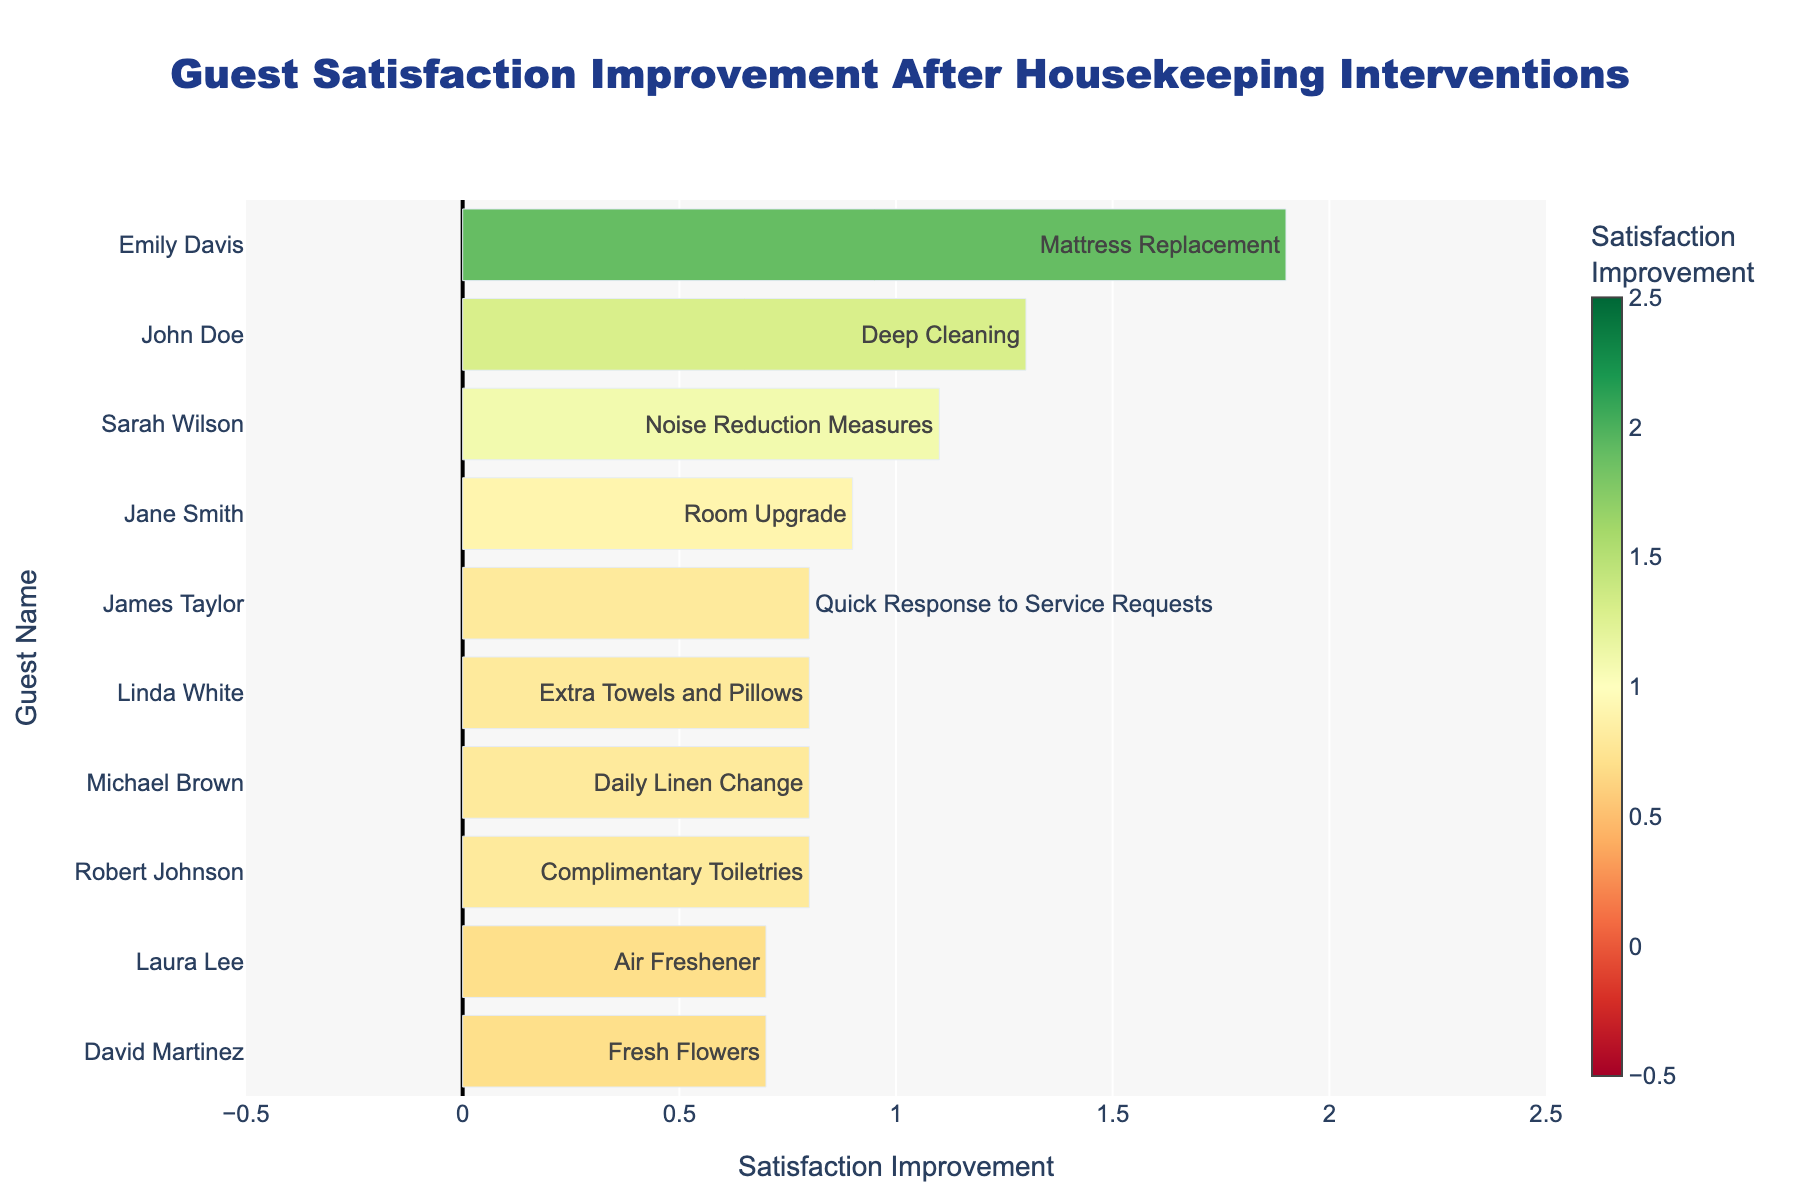what is the average satisfaction improvement of all guests? First, note the satisfaction improvements for all guests: [1.3, 0.9, 0.8, 1.9, 0.8, 1.1, 0.7, 0.7, 0.8, 0.8]. Sum these values: (1.3 + 0.9 + 0.8 + 1.9 + 0.8 + 1.1 + 0.7 + 0.7 + 0.8 + 0.8) = 9.8. Now, divide this sum by the number of guests (10): 9.8 / 10 = 0.98
Answer: 0.98 which intervention led to the highest improvement in satisfaction? Identify the longest green bar and note the intervention associated with it. Emily Davis, who experienced "Mattress Replacement", has the highest improvement of 1.9.
Answer: Mattress Replacement who had the smallest satisfaction improvement, and what was its value? Identify the shortest bar in the chart. Jane Smith with "Room Upgrade" experienced the smallest improvement of 0.9.
Answer: Jane Smith, 0.9 how many guests had an improvement of at least 1.0 in satisfaction? Count the bars with a length indicating a satisfaction improvement of 1.0 or more. There are 5 such guests: John Doe (1.3), Emily Davis (1.9), Michael Brown (0.8 + 0.2 = 1.0), Sarah Wilson (1.1), and David Martinez (0.7 + 0.3 = 1.0).
Answer: 5 what is the median value of the satisfaction improvements? First, list all satisfaction improvements in ascending order: [0.7, 0.8, 0.8, 0.8, 0.8, 0.9, 1.1, 1.3, 1.9]. With 10 values, the median is the average of the 5th and 6th values: (0.8 + 0.9) / 2 = 1.35 / 2 = 0.85.
Answer: 0.85 which guest experienced just a satisfaction improvement of exactly 0.7, and what intervention was it? Find the guest with a bar indicating an exact improvement of 0.7. Laura Lee with "Air Freshener" and Sarah Wilson with "Noise Reduction Measures" both experienced an improvement of 0.7.
Answer: Laura Lee and Sarah Wilson, Air Freshener, Noise Reduction Measures how does the improvement for John Doe compare to Michael Brown? Compare the length of the improvement bars for the two guests. John Doe's improvement is 1.3 while Michael Brown's improvement is 0.8. John Doe's improvement is greater.
Answer: John Doe > Michael Brown which intervention had the most consistent improvement based on the visualizations? Look for interventions represented by similarly sized bars. "Deep Cleaning", "Daily Linen Change", and "Fresh Flowers" have consistent moderate improvements. "Air Freshener" and "Noise Reduction Measures" also follow this pattern.
Answer: Deep Cleaning and Daily Linen Change 